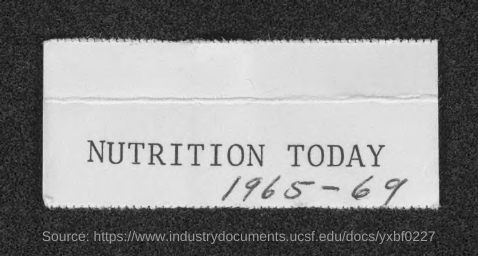Which Journal is mentioned here?
Ensure brevity in your answer.  NUTRITION TODAY. 